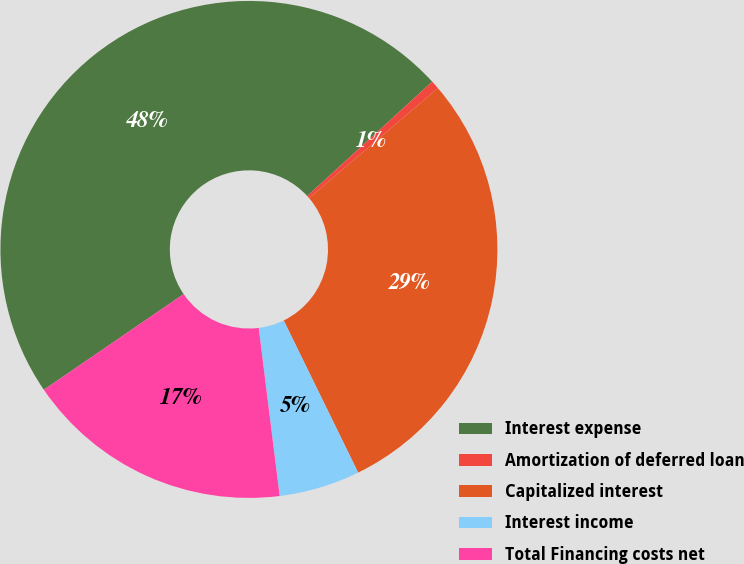Convert chart. <chart><loc_0><loc_0><loc_500><loc_500><pie_chart><fcel>Interest expense<fcel>Amortization of deferred loan<fcel>Capitalized interest<fcel>Interest income<fcel>Total Financing costs net<nl><fcel>47.75%<fcel>0.55%<fcel>29.0%<fcel>5.27%<fcel>17.42%<nl></chart> 